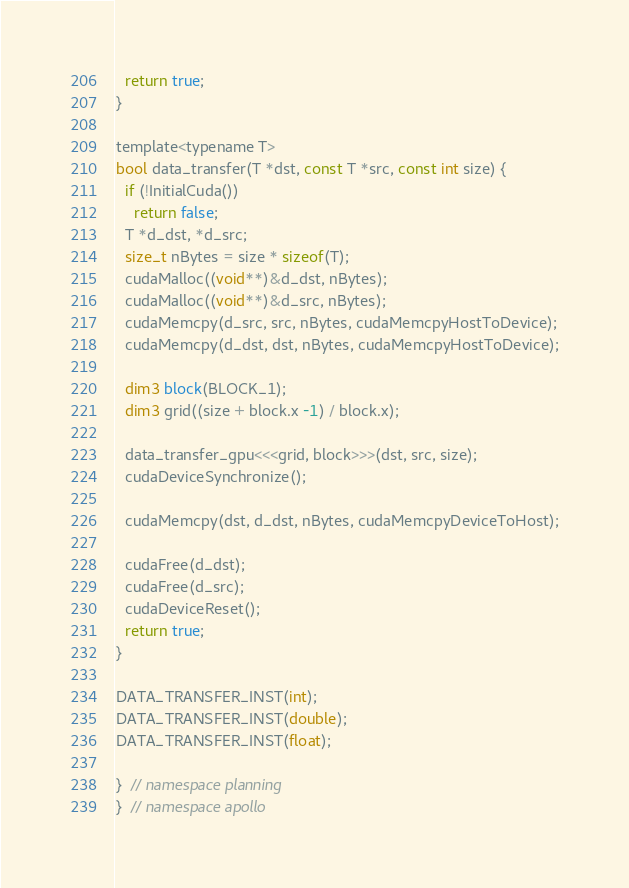Convert code to text. <code><loc_0><loc_0><loc_500><loc_500><_Cuda_>  return true;
}

template<typename T>
bool data_transfer(T *dst, const T *src, const int size) {
  if (!InitialCuda())
    return false;
  T *d_dst, *d_src;
  size_t nBytes = size * sizeof(T);
  cudaMalloc((void**)&d_dst, nBytes);
  cudaMalloc((void**)&d_src, nBytes);
  cudaMemcpy(d_src, src, nBytes, cudaMemcpyHostToDevice);
  cudaMemcpy(d_dst, dst, nBytes, cudaMemcpyHostToDevice);

  dim3 block(BLOCK_1);
  dim3 grid((size + block.x -1) / block.x);

  data_transfer_gpu<<<grid, block>>>(dst, src, size);
  cudaDeviceSynchronize();

  cudaMemcpy(dst, d_dst, nBytes, cudaMemcpyDeviceToHost);

  cudaFree(d_dst);
  cudaFree(d_src);
  cudaDeviceReset();
  return true;
}

DATA_TRANSFER_INST(int);
DATA_TRANSFER_INST(double);
DATA_TRANSFER_INST(float);

}  // namespace planning
}  // namespace apollo
</code> 